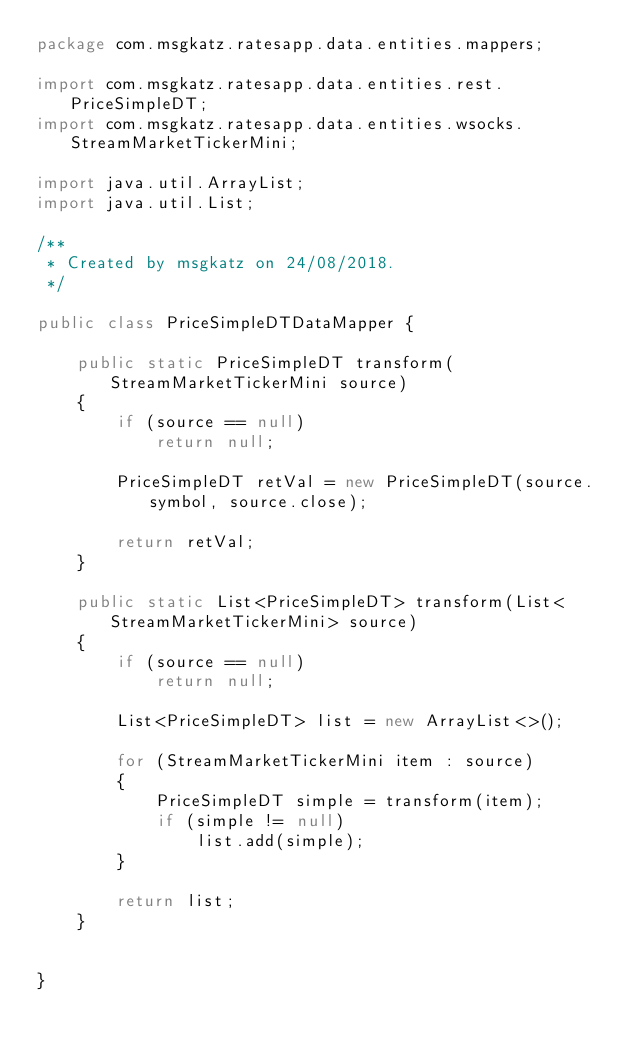<code> <loc_0><loc_0><loc_500><loc_500><_Java_>package com.msgkatz.ratesapp.data.entities.mappers;

import com.msgkatz.ratesapp.data.entities.rest.PriceSimpleDT;
import com.msgkatz.ratesapp.data.entities.wsocks.StreamMarketTickerMini;

import java.util.ArrayList;
import java.util.List;

/**
 * Created by msgkatz on 24/08/2018.
 */

public class PriceSimpleDTDataMapper {

    public static PriceSimpleDT transform(StreamMarketTickerMini source)
    {
        if (source == null)
            return null;

        PriceSimpleDT retVal = new PriceSimpleDT(source.symbol, source.close);

        return retVal;
    }

    public static List<PriceSimpleDT> transform(List<StreamMarketTickerMini> source)
    {
        if (source == null)
            return null;

        List<PriceSimpleDT> list = new ArrayList<>();

        for (StreamMarketTickerMini item : source)
        {
            PriceSimpleDT simple = transform(item);
            if (simple != null)
                list.add(simple);
        }

        return list;
    }


}
</code> 